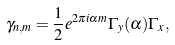<formula> <loc_0><loc_0><loc_500><loc_500>\gamma _ { n , m } = \frac { 1 } { 2 } e ^ { 2 \pi i \alpha m } \Gamma _ { y } ( \alpha ) \Gamma _ { x } ,</formula> 